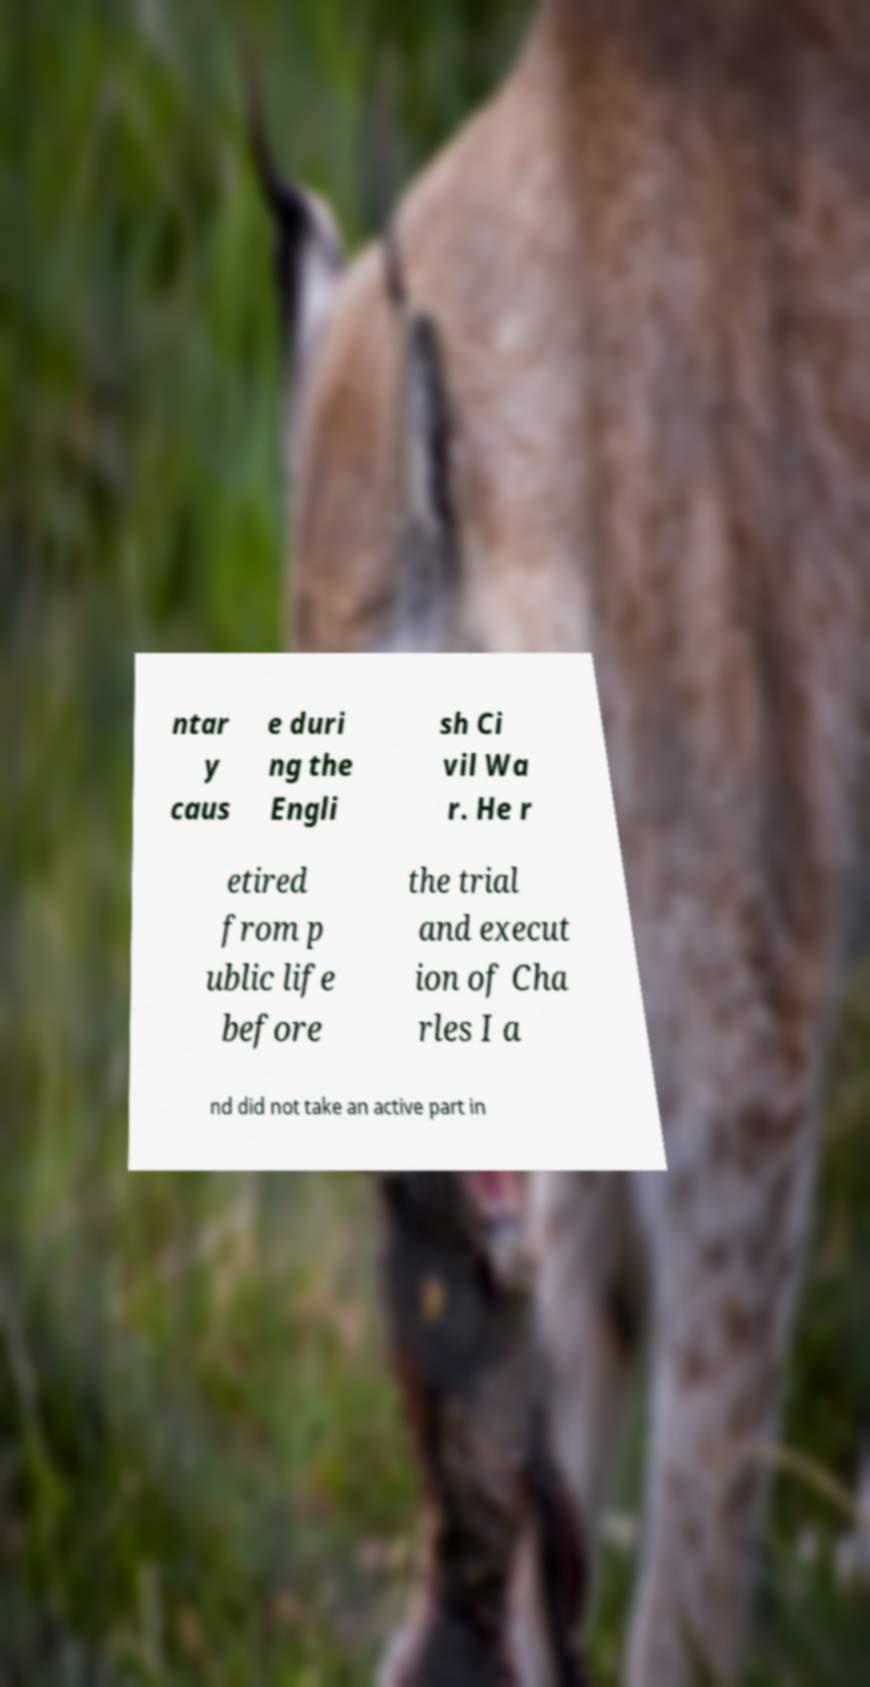Please identify and transcribe the text found in this image. ntar y caus e duri ng the Engli sh Ci vil Wa r. He r etired from p ublic life before the trial and execut ion of Cha rles I a nd did not take an active part in 